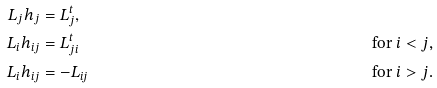Convert formula to latex. <formula><loc_0><loc_0><loc_500><loc_500>L _ { j } h _ { j } & = L _ { j } ^ { t } , \\ L _ { i } h _ { i j } & = L _ { j i } ^ { t } & & \text {for $i<j$,} \\ L _ { i } h _ { i j } & = - L _ { i j } & & \text {for $i>j$.}</formula> 